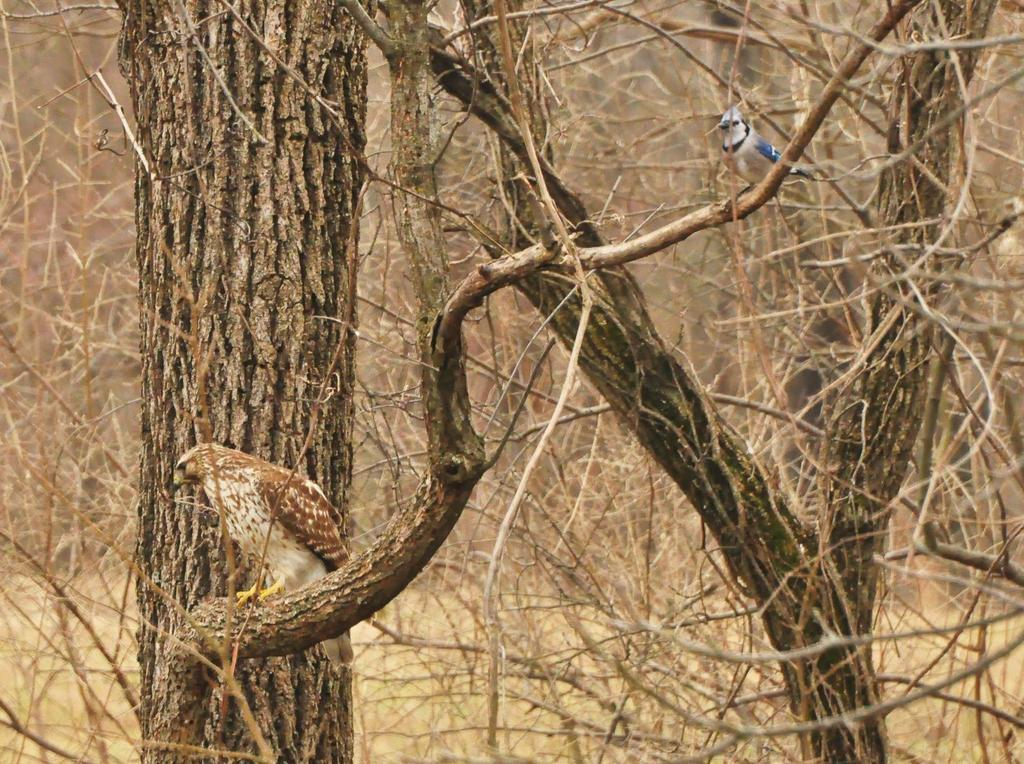What type of animals can be seen in the image? There are birds in the image. Where are the birds located? The birds are on the branch of a tree. What can be seen in the background of the image? There are bare trees in the background of the image. What type of cake is being eaten by the bird with a fang in the image? There is no bird with a fang eating a cake in the image, as there are no cakes or fangs present. 